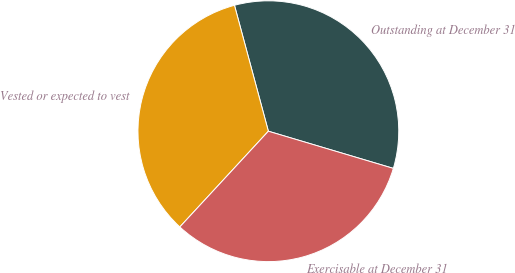<chart> <loc_0><loc_0><loc_500><loc_500><pie_chart><fcel>Outstanding at December 31<fcel>Vested or expected to vest<fcel>Exercisable at December 31<nl><fcel>33.79%<fcel>33.94%<fcel>32.28%<nl></chart> 